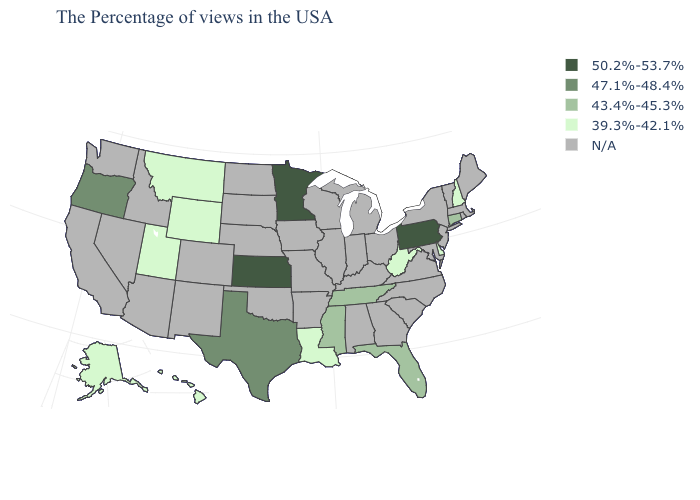Among the states that border Missouri , which have the lowest value?
Be succinct. Tennessee. What is the value of Kentucky?
Quick response, please. N/A. What is the highest value in the USA?
Give a very brief answer. 50.2%-53.7%. What is the value of Delaware?
Answer briefly. 39.3%-42.1%. What is the highest value in the West ?
Keep it brief. 47.1%-48.4%. Among the states that border Virginia , does Tennessee have the lowest value?
Quick response, please. No. Among the states that border Arkansas , does Mississippi have the lowest value?
Give a very brief answer. No. Is the legend a continuous bar?
Concise answer only. No. Name the states that have a value in the range 47.1%-48.4%?
Answer briefly. Texas, Oregon. What is the value of West Virginia?
Quick response, please. 39.3%-42.1%. Name the states that have a value in the range 39.3%-42.1%?
Write a very short answer. New Hampshire, Delaware, West Virginia, Louisiana, Wyoming, Utah, Montana, Alaska, Hawaii. Among the states that border Maryland , does Pennsylvania have the highest value?
Concise answer only. Yes. 